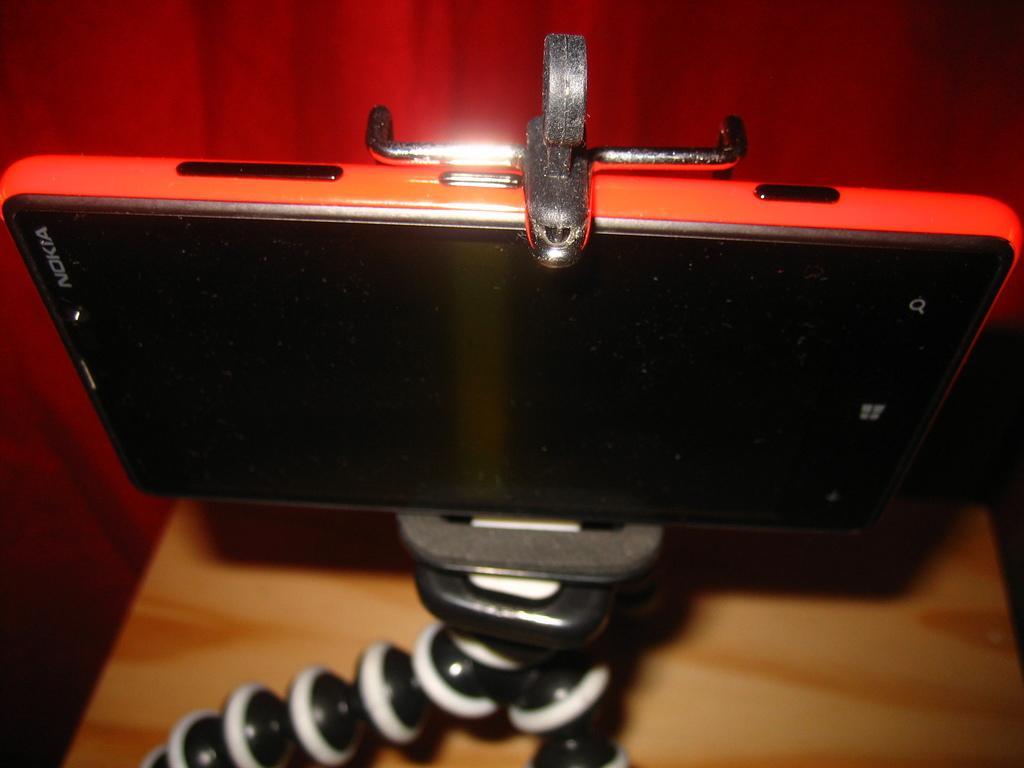Can you describe this image briefly? In this image there is a table towards the bottom of the image, there is a stance towards the bottom of the image, there is a mobile phone, at the background of the image there is a curtain. 